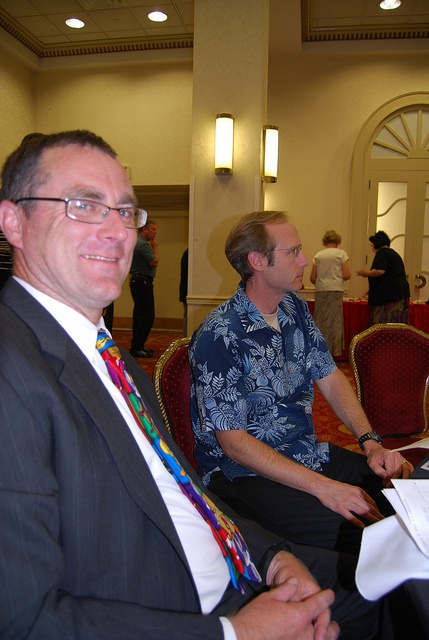Describe the objects in this image and their specific colors. I can see people in black, brown, and lightpink tones, people in black, brown, navy, and gray tones, chair in black, maroon, and olive tones, tie in black, navy, maroon, and blue tones, and chair in black, maroon, and olive tones in this image. 